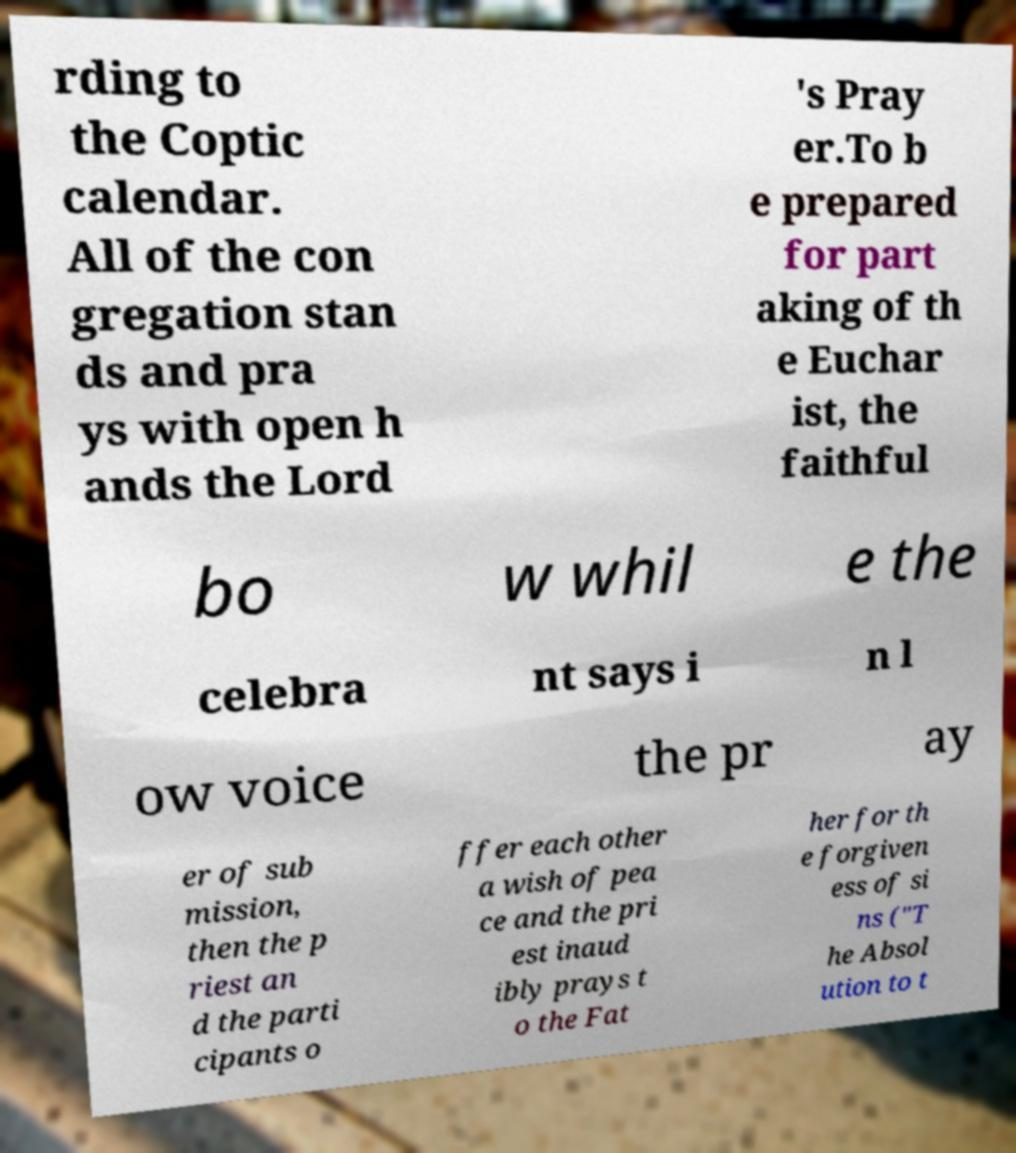Could you extract and type out the text from this image? rding to the Coptic calendar. All of the con gregation stan ds and pra ys with open h ands the Lord 's Pray er.To b e prepared for part aking of th e Euchar ist, the faithful bo w whil e the celebra nt says i n l ow voice the pr ay er of sub mission, then the p riest an d the parti cipants o ffer each other a wish of pea ce and the pri est inaud ibly prays t o the Fat her for th e forgiven ess of si ns ("T he Absol ution to t 